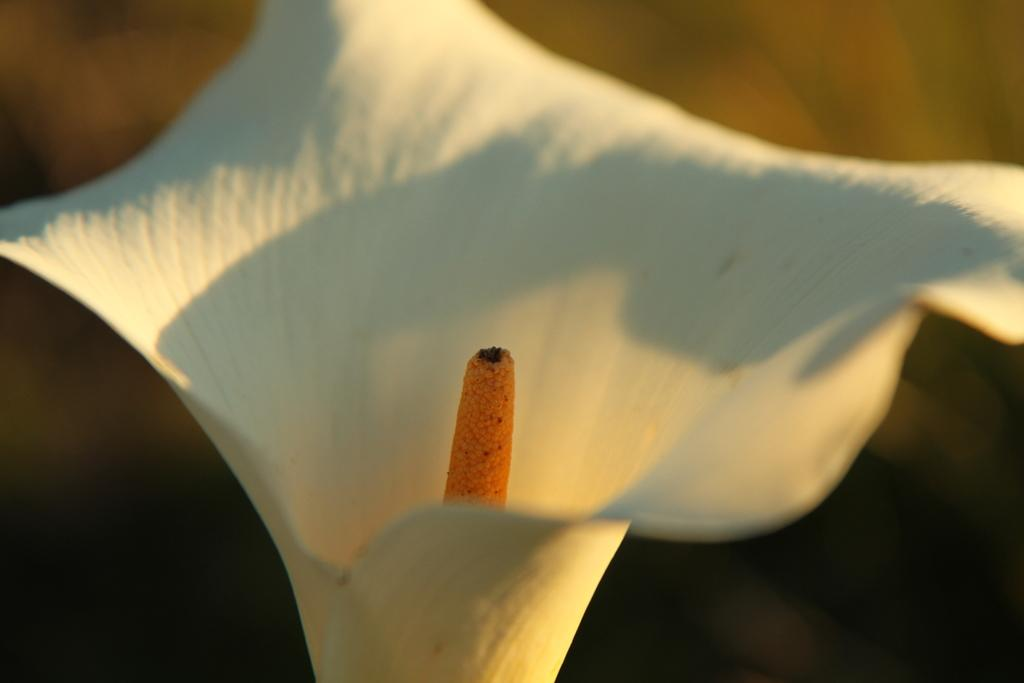What type of flower is present in the image? There is a white and orange color flower in the image. Can you describe the background of the image? The background of the image is in brown and black colors. What date is marked on the calendar in the image? There is no calendar present in the image. What type of work is being done in the office in the image? There is no office or work-related activity depicted in the image. 